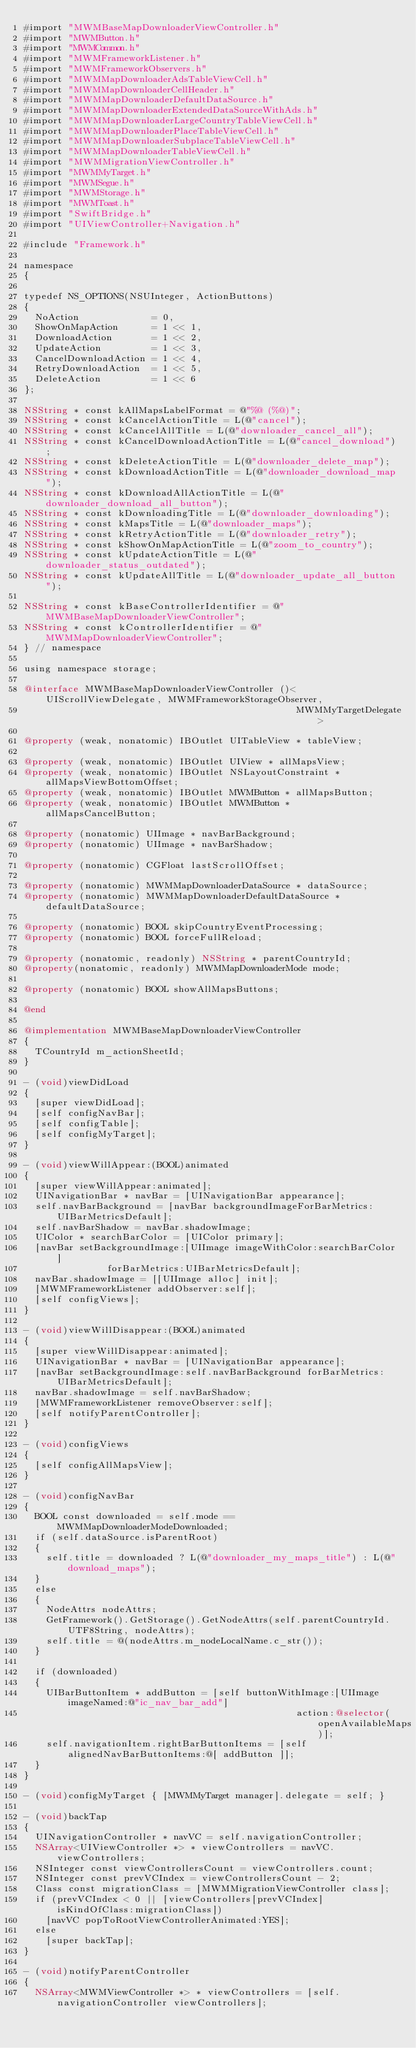Convert code to text. <code><loc_0><loc_0><loc_500><loc_500><_ObjectiveC_>#import "MWMBaseMapDownloaderViewController.h"
#import "MWMButton.h"
#import "MWMCommon.h"
#import "MWMFrameworkListener.h"
#import "MWMFrameworkObservers.h"
#import "MWMMapDownloaderAdsTableViewCell.h"
#import "MWMMapDownloaderCellHeader.h"
#import "MWMMapDownloaderDefaultDataSource.h"
#import "MWMMapDownloaderExtendedDataSourceWithAds.h"
#import "MWMMapDownloaderLargeCountryTableViewCell.h"
#import "MWMMapDownloaderPlaceTableViewCell.h"
#import "MWMMapDownloaderSubplaceTableViewCell.h"
#import "MWMMapDownloaderTableViewCell.h"
#import "MWMMigrationViewController.h"
#import "MWMMyTarget.h"
#import "MWMSegue.h"
#import "MWMStorage.h"
#import "MWMToast.h"
#import "SwiftBridge.h"
#import "UIViewController+Navigation.h"

#include "Framework.h"

namespace
{

typedef NS_OPTIONS(NSUInteger, ActionButtons)
{
  NoAction             = 0,
  ShowOnMapAction      = 1 << 1,
  DownloadAction       = 1 << 2,
  UpdateAction         = 1 << 3,
  CancelDownloadAction = 1 << 4,
  RetryDownloadAction  = 1 << 5,
  DeleteAction         = 1 << 6
};

NSString * const kAllMapsLabelFormat = @"%@ (%@)";
NSString * const kCancelActionTitle = L(@"cancel");
NSString * const kCancelAllTitle = L(@"downloader_cancel_all");
NSString * const kCancelDownloadActionTitle = L(@"cancel_download");
NSString * const kDeleteActionTitle = L(@"downloader_delete_map");
NSString * const kDownloadActionTitle = L(@"downloader_download_map");
NSString * const kDownloadAllActionTitle = L(@"downloader_download_all_button");
NSString * const kDownloadingTitle = L(@"downloader_downloading");
NSString * const kMapsTitle = L(@"downloader_maps");
NSString * const kRetryActionTitle = L(@"downloader_retry");
NSString * const kShowOnMapActionTitle = L(@"zoom_to_country");
NSString * const kUpdateActionTitle = L(@"downloader_status_outdated");
NSString * const kUpdateAllTitle = L(@"downloader_update_all_button");

NSString * const kBaseControllerIdentifier = @"MWMBaseMapDownloaderViewController";
NSString * const kControllerIdentifier = @"MWMMapDownloaderViewController";
} // namespace

using namespace storage;

@interface MWMBaseMapDownloaderViewController ()<UIScrollViewDelegate, MWMFrameworkStorageObserver,
                                                 MWMMyTargetDelegate>

@property (weak, nonatomic) IBOutlet UITableView * tableView;

@property (weak, nonatomic) IBOutlet UIView * allMapsView;
@property (weak, nonatomic) IBOutlet NSLayoutConstraint * allMapsViewBottomOffset;
@property (weak, nonatomic) IBOutlet MWMButton * allMapsButton;
@property (weak, nonatomic) IBOutlet MWMButton * allMapsCancelButton;

@property (nonatomic) UIImage * navBarBackground;
@property (nonatomic) UIImage * navBarShadow;

@property (nonatomic) CGFloat lastScrollOffset;

@property (nonatomic) MWMMapDownloaderDataSource * dataSource;
@property (nonatomic) MWMMapDownloaderDefaultDataSource * defaultDataSource;

@property (nonatomic) BOOL skipCountryEventProcessing;
@property (nonatomic) BOOL forceFullReload;

@property (nonatomic, readonly) NSString * parentCountryId;
@property(nonatomic, readonly) MWMMapDownloaderMode mode;

@property (nonatomic) BOOL showAllMapsButtons;

@end

@implementation MWMBaseMapDownloaderViewController
{
  TCountryId m_actionSheetId;
}

- (void)viewDidLoad
{
  [super viewDidLoad];
  [self configNavBar];
  [self configTable];
  [self configMyTarget];
}

- (void)viewWillAppear:(BOOL)animated
{
  [super viewWillAppear:animated];
  UINavigationBar * navBar = [UINavigationBar appearance];
  self.navBarBackground = [navBar backgroundImageForBarMetrics:UIBarMetricsDefault];
  self.navBarShadow = navBar.shadowImage;
  UIColor * searchBarColor = [UIColor primary];
  [navBar setBackgroundImage:[UIImage imageWithColor:searchBarColor]
               forBarMetrics:UIBarMetricsDefault];
  navBar.shadowImage = [[UIImage alloc] init];
  [MWMFrameworkListener addObserver:self];
  [self configViews];
}

- (void)viewWillDisappear:(BOOL)animated
{
  [super viewWillDisappear:animated];
  UINavigationBar * navBar = [UINavigationBar appearance];
  [navBar setBackgroundImage:self.navBarBackground forBarMetrics:UIBarMetricsDefault];
  navBar.shadowImage = self.navBarShadow;
  [MWMFrameworkListener removeObserver:self];
  [self notifyParentController];
}

- (void)configViews
{
  [self configAllMapsView];
}

- (void)configNavBar
{
  BOOL const downloaded = self.mode == MWMMapDownloaderModeDownloaded;
  if (self.dataSource.isParentRoot)
  {
    self.title = downloaded ? L(@"downloader_my_maps_title") : L(@"download_maps");
  }
  else
  {
    NodeAttrs nodeAttrs;
    GetFramework().GetStorage().GetNodeAttrs(self.parentCountryId.UTF8String, nodeAttrs);
    self.title = @(nodeAttrs.m_nodeLocalName.c_str());
  }

  if (downloaded)
  {
    UIBarButtonItem * addButton = [self buttonWithImage:[UIImage imageNamed:@"ic_nav_bar_add"]
                                                 action:@selector(openAvailableMaps)];
    self.navigationItem.rightBarButtonItems = [self alignedNavBarButtonItems:@[ addButton ]];
  }
}

- (void)configMyTarget { [MWMMyTarget manager].delegate = self; }

- (void)backTap
{
  UINavigationController * navVC = self.navigationController;
  NSArray<UIViewController *> * viewControllers = navVC.viewControllers;
  NSInteger const viewControllersCount = viewControllers.count;
  NSInteger const prevVCIndex = viewControllersCount - 2;
  Class const migrationClass = [MWMMigrationViewController class];
  if (prevVCIndex < 0 || [viewControllers[prevVCIndex] isKindOfClass:migrationClass])
    [navVC popToRootViewControllerAnimated:YES];
  else
    [super backTap];
}

- (void)notifyParentController
{
  NSArray<MWMViewController *> * viewControllers = [self.navigationController viewControllers];</code> 